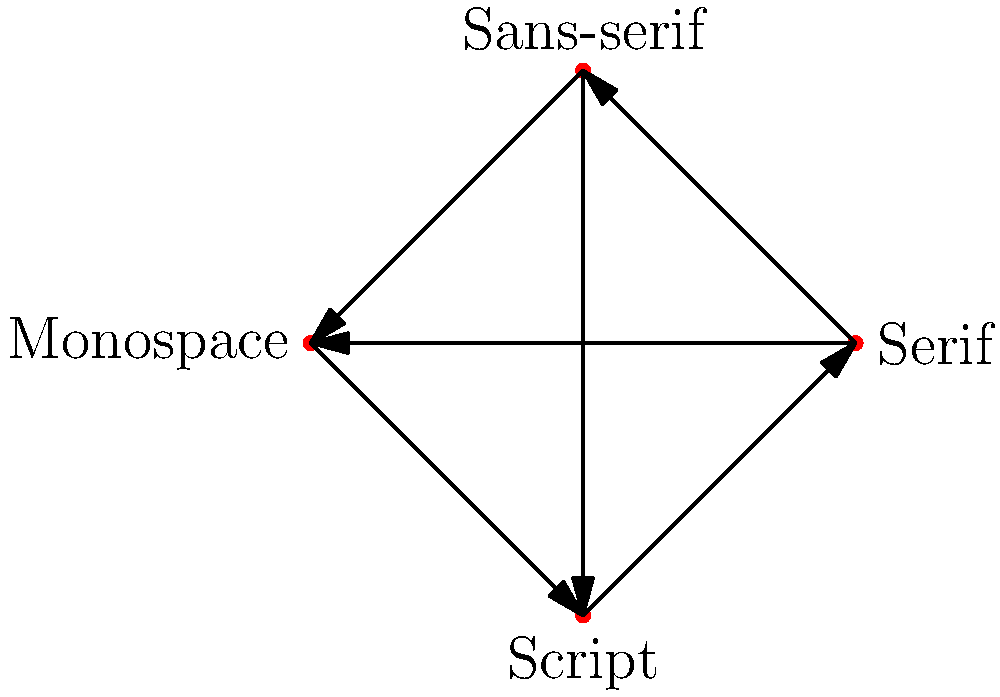As a retired newspaper editor, you're analyzing the group structure of different font families used in newspaper typography. The diagram represents a group with four elements: Serif, Sans-serif, Monospace, and Script fonts. Edges represent possible transformations between fonts. If we define the group operation as consecutive transformations, what is the order of the subgroup generated by the transformation from Serif to Sans-serif? To determine the order of the subgroup generated by the transformation from Serif to Sans-serif, we need to follow these steps:

1. Identify the transformation: Serif to Sans-serif
2. Apply the transformation repeatedly until we return to the starting point (Serif)

Let's trace the transformations:
- Start: Serif
- 1st application: Sans-serif
- 2nd application: Monospace
- 3rd application: Script
- 4th application: Serif (back to the start)

We can see that it takes 4 applications of the transformation to return to the starting point. This means that the transformation from Serif to Sans-serif generates a cyclic subgroup of order 4.

In group theory terms:
Let $g$ be the transformation from Serif to Sans-serif.
The subgroup generated by $g$ is $\langle g \rangle = \{e, g, g^2, g^3\}$, where:
- $e$ is the identity (no transformation)
- $g$ is Serif to Sans-serif
- $g^2$ is Sans-serif to Monospace
- $g^3$ is Monospace to Script

The order of a group is the number of elements it contains. In this case, the subgroup $\langle g \rangle$ has 4 elements.

Therefore, the order of the subgroup generated by the transformation from Serif to Sans-serif is 4.
Answer: 4 